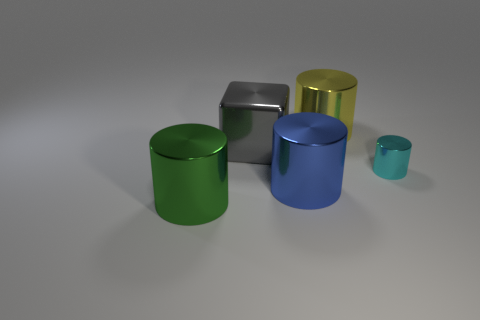Subtract all large green cylinders. How many cylinders are left? 3 Add 3 tiny red rubber blocks. How many objects exist? 8 Subtract all cyan cylinders. How many cylinders are left? 3 Subtract all cubes. How many objects are left? 4 Subtract all brown cylinders. Subtract all brown blocks. How many cylinders are left? 4 Subtract all green cylinders. How many brown cubes are left? 0 Subtract all tiny cyan metallic things. Subtract all large metallic blocks. How many objects are left? 3 Add 2 big green metallic cylinders. How many big green metallic cylinders are left? 3 Add 5 large yellow metal cylinders. How many large yellow metal cylinders exist? 6 Subtract 0 red cylinders. How many objects are left? 5 